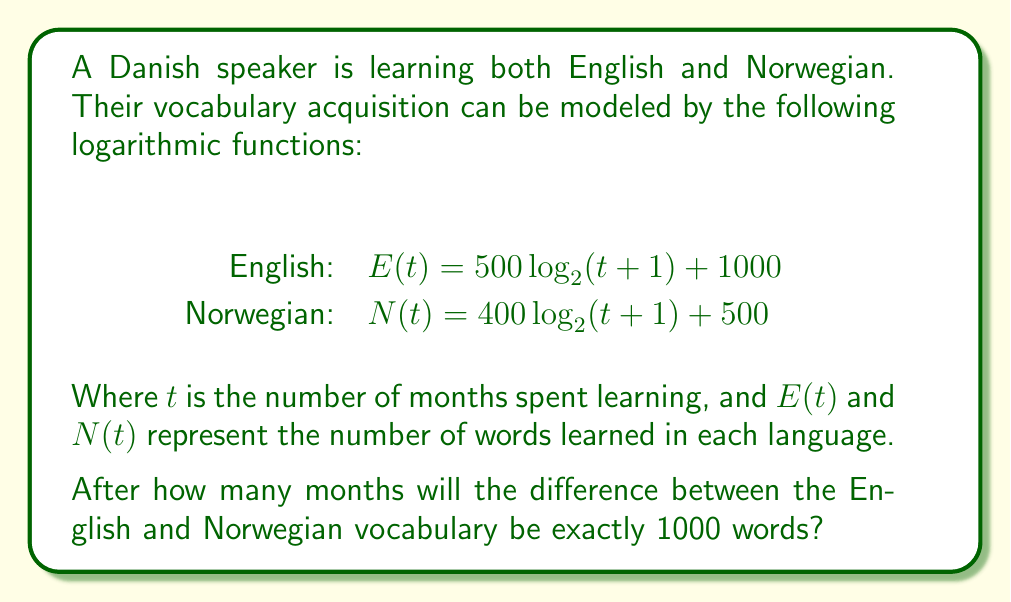Can you answer this question? Let's approach this step-by-step:

1) We need to find $t$ where $E(t) - N(t) = 1000$

2) Let's substitute the given functions:
   $$(500 \log_2(t+1) + 1000) - (400 \log_2(t+1) + 500) = 1000$$

3) Simplify:
   $$500 \log_2(t+1) + 1000 - 400 \log_2(t+1) - 500 = 1000$$
   $$100 \log_2(t+1) + 500 = 1000$$

4) Subtract 500 from both sides:
   $$100 \log_2(t+1) = 500$$

5) Divide both sides by 100:
   $$\log_2(t+1) = 5$$

6) To solve for $t$, we need to apply $2^x$ to both sides:
   $$2^{\log_2(t+1)} = 2^5$$

7) The left side simplifies to $t+1$:
   $$t + 1 = 32$$

8) Subtract 1 from both sides:
   $$t = 31$$

Therefore, after 31 months, the difference between English and Norwegian vocabulary will be exactly 1000 words.
Answer: 31 months 